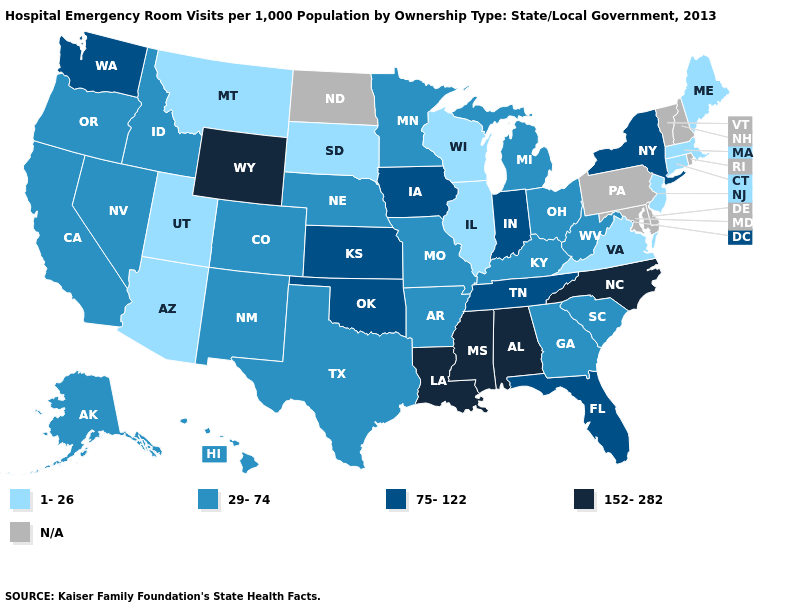Name the states that have a value in the range 1-26?
Answer briefly. Arizona, Connecticut, Illinois, Maine, Massachusetts, Montana, New Jersey, South Dakota, Utah, Virginia, Wisconsin. Does Indiana have the lowest value in the USA?
Write a very short answer. No. Name the states that have a value in the range 152-282?
Short answer required. Alabama, Louisiana, Mississippi, North Carolina, Wyoming. Name the states that have a value in the range 29-74?
Answer briefly. Alaska, Arkansas, California, Colorado, Georgia, Hawaii, Idaho, Kentucky, Michigan, Minnesota, Missouri, Nebraska, Nevada, New Mexico, Ohio, Oregon, South Carolina, Texas, West Virginia. Name the states that have a value in the range 29-74?
Concise answer only. Alaska, Arkansas, California, Colorado, Georgia, Hawaii, Idaho, Kentucky, Michigan, Minnesota, Missouri, Nebraska, Nevada, New Mexico, Ohio, Oregon, South Carolina, Texas, West Virginia. Name the states that have a value in the range N/A?
Write a very short answer. Delaware, Maryland, New Hampshire, North Dakota, Pennsylvania, Rhode Island, Vermont. Which states have the lowest value in the South?
Give a very brief answer. Virginia. What is the value of Alabama?
Be succinct. 152-282. Among the states that border Georgia , does Alabama have the highest value?
Give a very brief answer. Yes. Does South Dakota have the lowest value in the MidWest?
Keep it brief. Yes. Among the states that border Maryland , does Virginia have the lowest value?
Concise answer only. Yes. Does Kansas have the highest value in the MidWest?
Keep it brief. Yes. Does Missouri have the lowest value in the MidWest?
Answer briefly. No. 